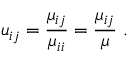Convert formula to latex. <formula><loc_0><loc_0><loc_500><loc_500>u _ { i j } = \frac { \mu _ { i j } } { \mu _ { i i } } = \frac { \mu _ { i j } } { \mu } \ .</formula> 